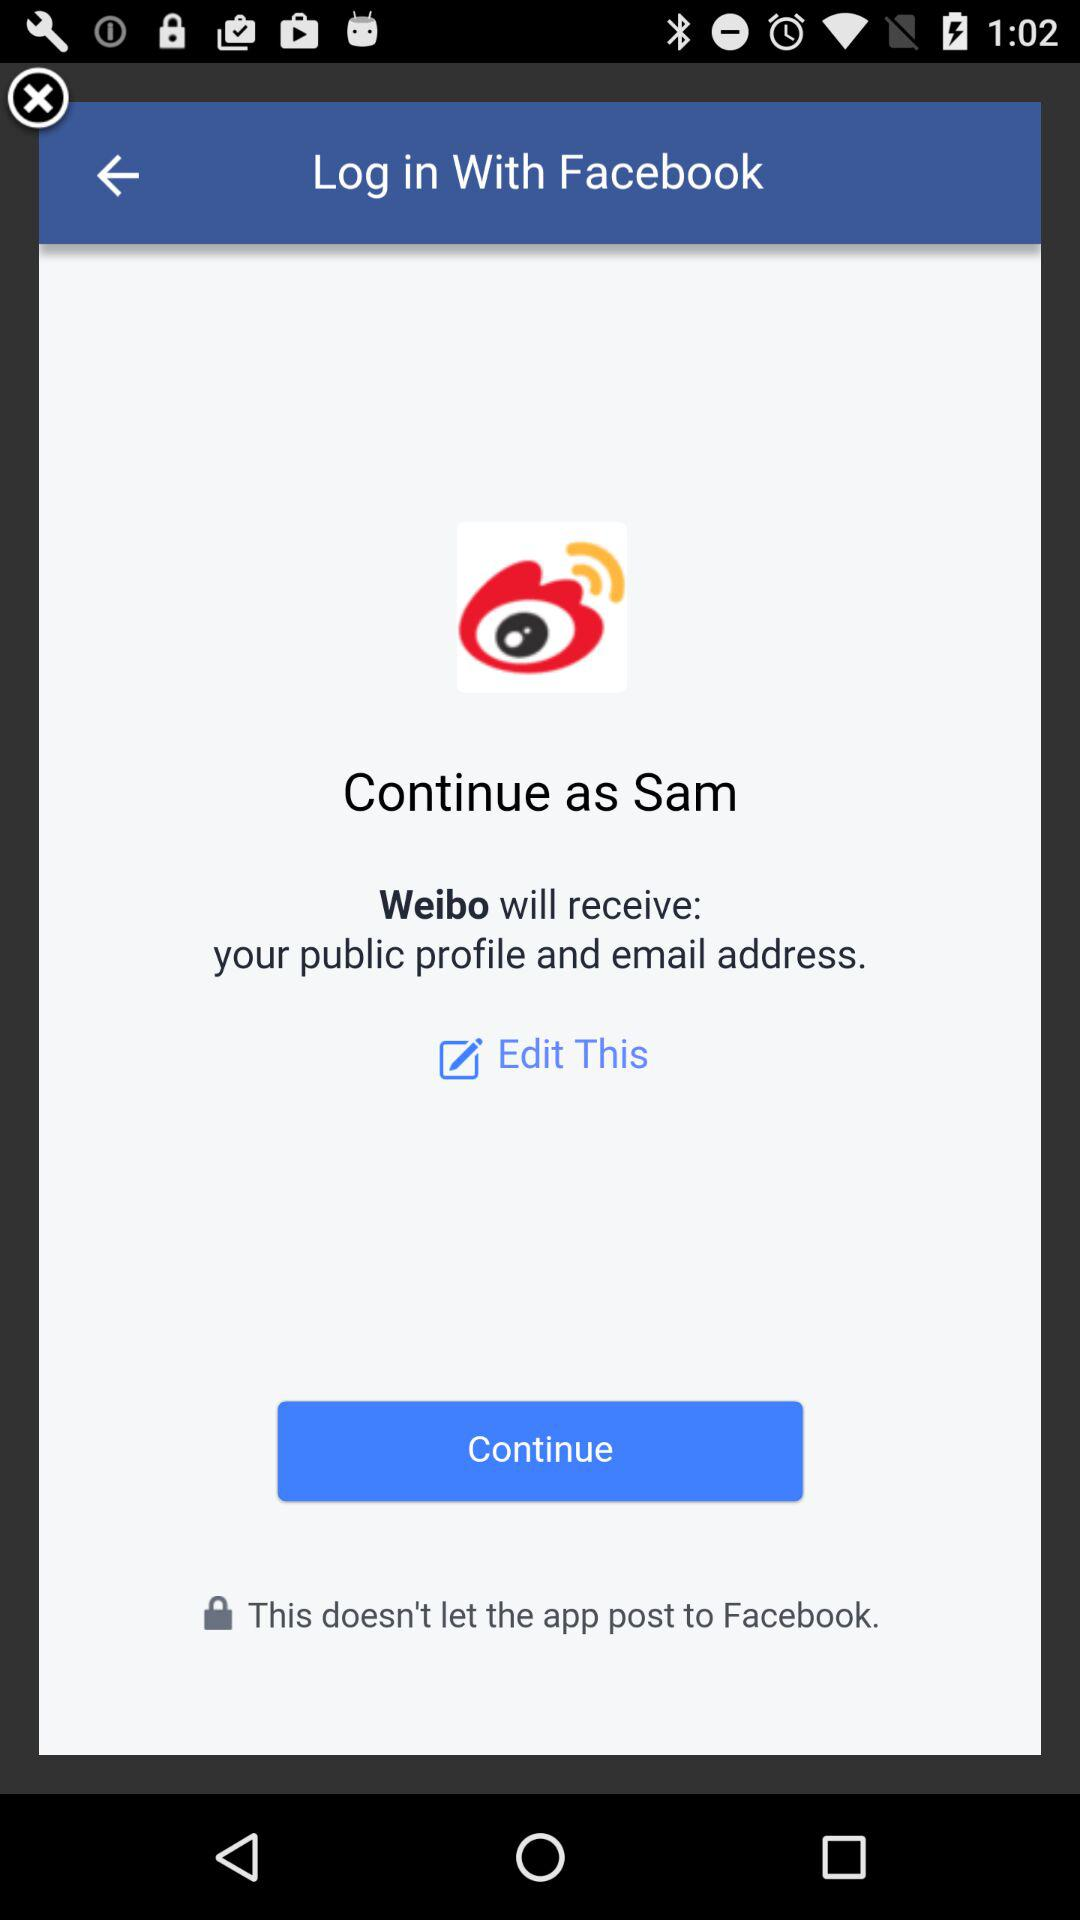What is the name of the user? The name of the user is Sam. 